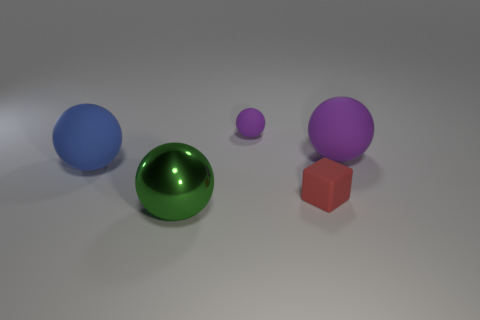What materials do the objects in the image appear to be made from? The objects in the image seem to be rendered with different types of materials. The spherical shapes and the cube have a matte finish suggesting a plastic or rubber-like material, whereas the green sphere has a reflective surface indicating a polished metal or glass material. 